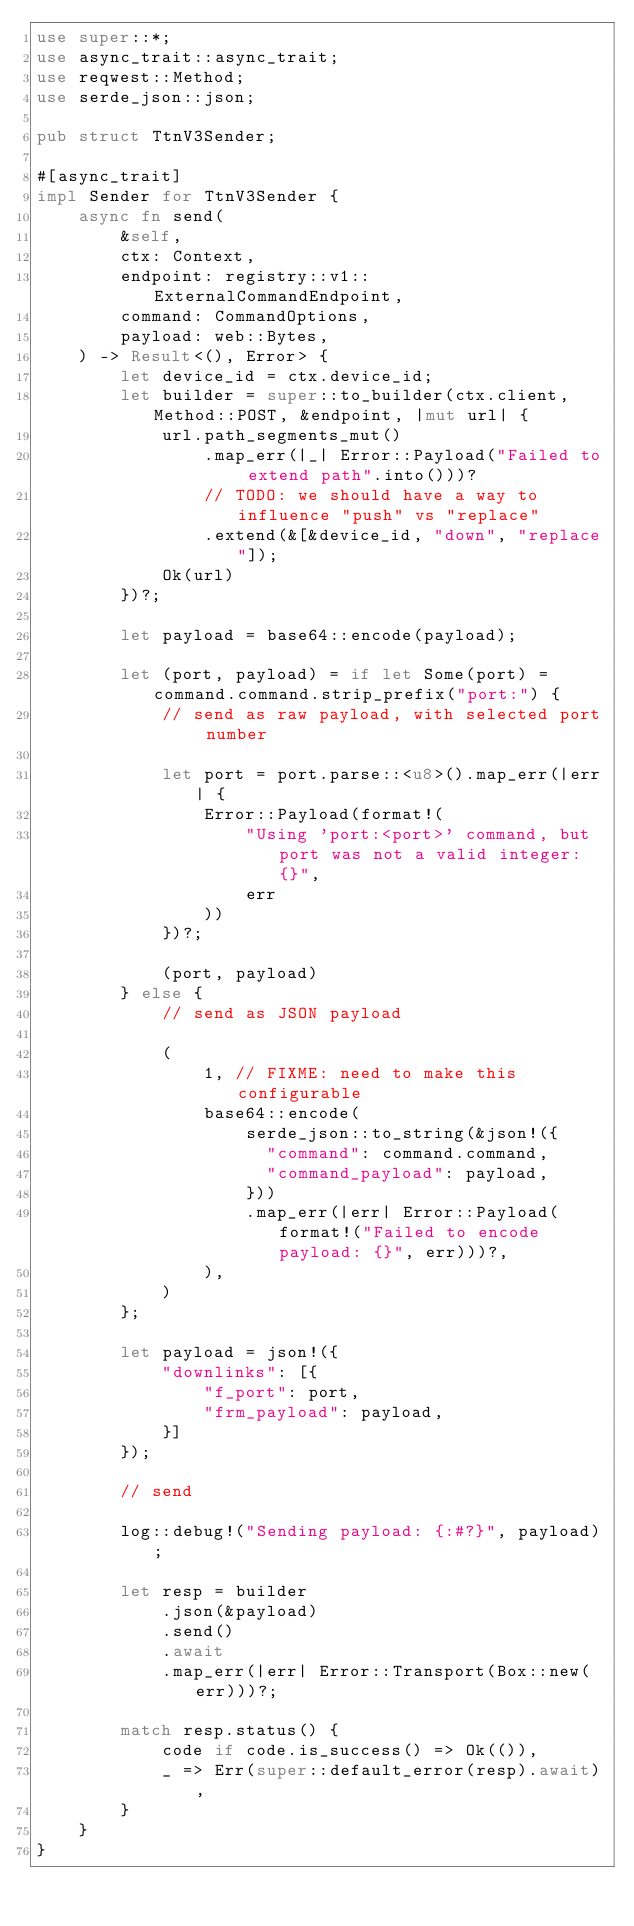<code> <loc_0><loc_0><loc_500><loc_500><_Rust_>use super::*;
use async_trait::async_trait;
use reqwest::Method;
use serde_json::json;

pub struct TtnV3Sender;

#[async_trait]
impl Sender for TtnV3Sender {
    async fn send(
        &self,
        ctx: Context,
        endpoint: registry::v1::ExternalCommandEndpoint,
        command: CommandOptions,
        payload: web::Bytes,
    ) -> Result<(), Error> {
        let device_id = ctx.device_id;
        let builder = super::to_builder(ctx.client, Method::POST, &endpoint, |mut url| {
            url.path_segments_mut()
                .map_err(|_| Error::Payload("Failed to extend path".into()))?
                // TODO: we should have a way to influence "push" vs "replace"
                .extend(&[&device_id, "down", "replace"]);
            Ok(url)
        })?;

        let payload = base64::encode(payload);

        let (port, payload) = if let Some(port) = command.command.strip_prefix("port:") {
            // send as raw payload, with selected port number

            let port = port.parse::<u8>().map_err(|err| {
                Error::Payload(format!(
                    "Using 'port:<port>' command, but port was not a valid integer: {}",
                    err
                ))
            })?;

            (port, payload)
        } else {
            // send as JSON payload

            (
                1, // FIXME: need to make this configurable
                base64::encode(
                    serde_json::to_string(&json!({
                      "command": command.command,
                      "command_payload": payload,
                    }))
                    .map_err(|err| Error::Payload(format!("Failed to encode payload: {}", err)))?,
                ),
            )
        };

        let payload = json!({
            "downlinks": [{
                "f_port": port,
                "frm_payload": payload,
            }]
        });

        // send

        log::debug!("Sending payload: {:#?}", payload);

        let resp = builder
            .json(&payload)
            .send()
            .await
            .map_err(|err| Error::Transport(Box::new(err)))?;

        match resp.status() {
            code if code.is_success() => Ok(()),
            _ => Err(super::default_error(resp).await),
        }
    }
}
</code> 